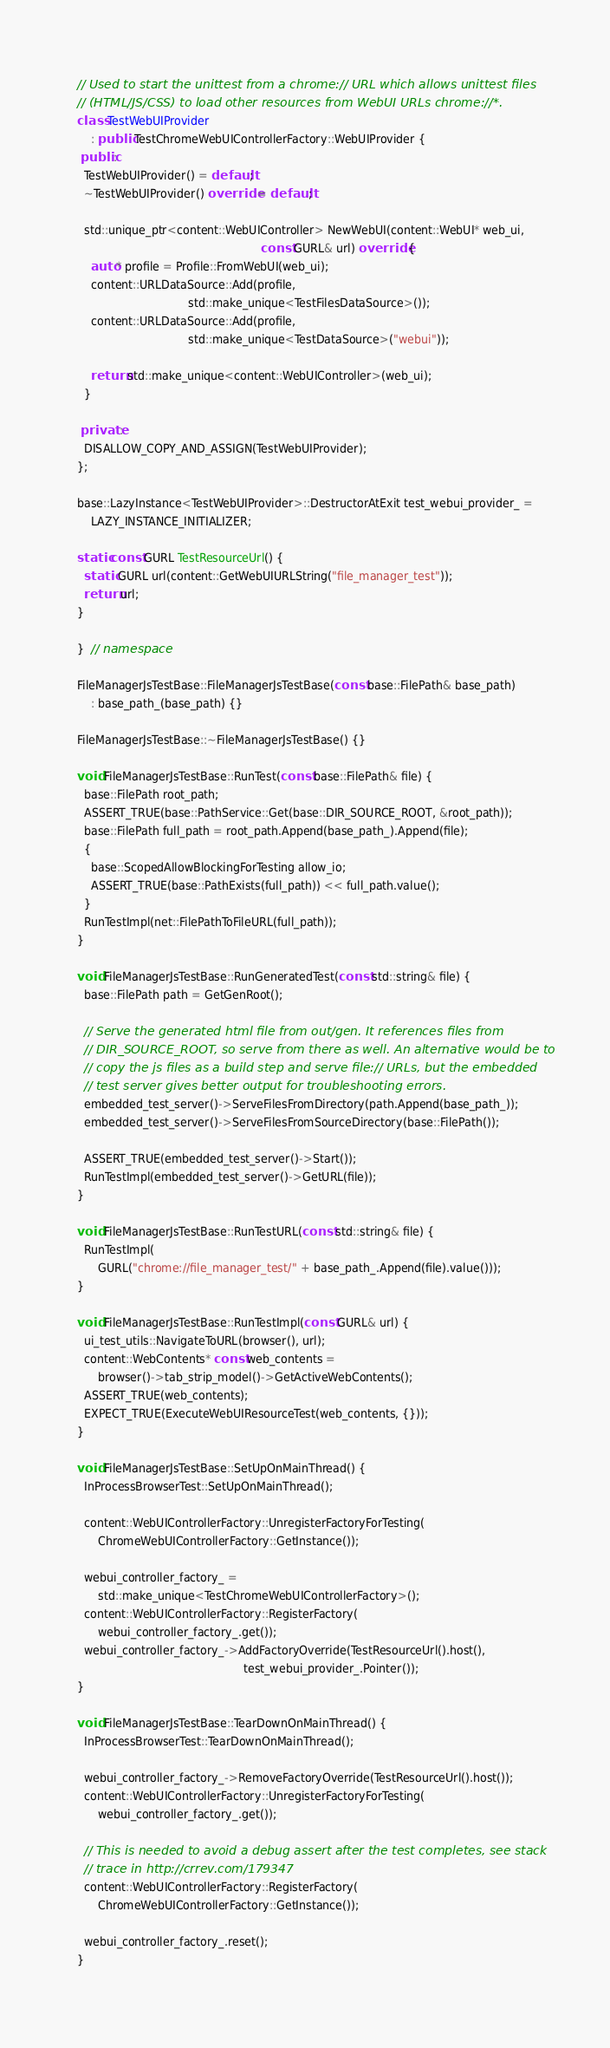<code> <loc_0><loc_0><loc_500><loc_500><_C++_>// Used to start the unittest from a chrome:// URL which allows unittest files
// (HTML/JS/CSS) to load other resources from WebUI URLs chrome://*.
class TestWebUIProvider
    : public TestChromeWebUIControllerFactory::WebUIProvider {
 public:
  TestWebUIProvider() = default;
  ~TestWebUIProvider() override = default;

  std::unique_ptr<content::WebUIController> NewWebUI(content::WebUI* web_ui,
                                                     const GURL& url) override {
    auto* profile = Profile::FromWebUI(web_ui);
    content::URLDataSource::Add(profile,
                                std::make_unique<TestFilesDataSource>());
    content::URLDataSource::Add(profile,
                                std::make_unique<TestDataSource>("webui"));

    return std::make_unique<content::WebUIController>(web_ui);
  }

 private:
  DISALLOW_COPY_AND_ASSIGN(TestWebUIProvider);
};

base::LazyInstance<TestWebUIProvider>::DestructorAtExit test_webui_provider_ =
    LAZY_INSTANCE_INITIALIZER;

static const GURL TestResourceUrl() {
  static GURL url(content::GetWebUIURLString("file_manager_test"));
  return url;
}

}  // namespace

FileManagerJsTestBase::FileManagerJsTestBase(const base::FilePath& base_path)
    : base_path_(base_path) {}

FileManagerJsTestBase::~FileManagerJsTestBase() {}

void FileManagerJsTestBase::RunTest(const base::FilePath& file) {
  base::FilePath root_path;
  ASSERT_TRUE(base::PathService::Get(base::DIR_SOURCE_ROOT, &root_path));
  base::FilePath full_path = root_path.Append(base_path_).Append(file);
  {
    base::ScopedAllowBlockingForTesting allow_io;
    ASSERT_TRUE(base::PathExists(full_path)) << full_path.value();
  }
  RunTestImpl(net::FilePathToFileURL(full_path));
}

void FileManagerJsTestBase::RunGeneratedTest(const std::string& file) {
  base::FilePath path = GetGenRoot();

  // Serve the generated html file from out/gen. It references files from
  // DIR_SOURCE_ROOT, so serve from there as well. An alternative would be to
  // copy the js files as a build step and serve file:// URLs, but the embedded
  // test server gives better output for troubleshooting errors.
  embedded_test_server()->ServeFilesFromDirectory(path.Append(base_path_));
  embedded_test_server()->ServeFilesFromSourceDirectory(base::FilePath());

  ASSERT_TRUE(embedded_test_server()->Start());
  RunTestImpl(embedded_test_server()->GetURL(file));
}

void FileManagerJsTestBase::RunTestURL(const std::string& file) {
  RunTestImpl(
      GURL("chrome://file_manager_test/" + base_path_.Append(file).value()));
}

void FileManagerJsTestBase::RunTestImpl(const GURL& url) {
  ui_test_utils::NavigateToURL(browser(), url);
  content::WebContents* const web_contents =
      browser()->tab_strip_model()->GetActiveWebContents();
  ASSERT_TRUE(web_contents);
  EXPECT_TRUE(ExecuteWebUIResourceTest(web_contents, {}));
}

void FileManagerJsTestBase::SetUpOnMainThread() {
  InProcessBrowserTest::SetUpOnMainThread();

  content::WebUIControllerFactory::UnregisterFactoryForTesting(
      ChromeWebUIControllerFactory::GetInstance());

  webui_controller_factory_ =
      std::make_unique<TestChromeWebUIControllerFactory>();
  content::WebUIControllerFactory::RegisterFactory(
      webui_controller_factory_.get());
  webui_controller_factory_->AddFactoryOverride(TestResourceUrl().host(),
                                                test_webui_provider_.Pointer());
}

void FileManagerJsTestBase::TearDownOnMainThread() {
  InProcessBrowserTest::TearDownOnMainThread();

  webui_controller_factory_->RemoveFactoryOverride(TestResourceUrl().host());
  content::WebUIControllerFactory::UnregisterFactoryForTesting(
      webui_controller_factory_.get());

  // This is needed to avoid a debug assert after the test completes, see stack
  // trace in http://crrev.com/179347
  content::WebUIControllerFactory::RegisterFactory(
      ChromeWebUIControllerFactory::GetInstance());

  webui_controller_factory_.reset();
}
</code> 